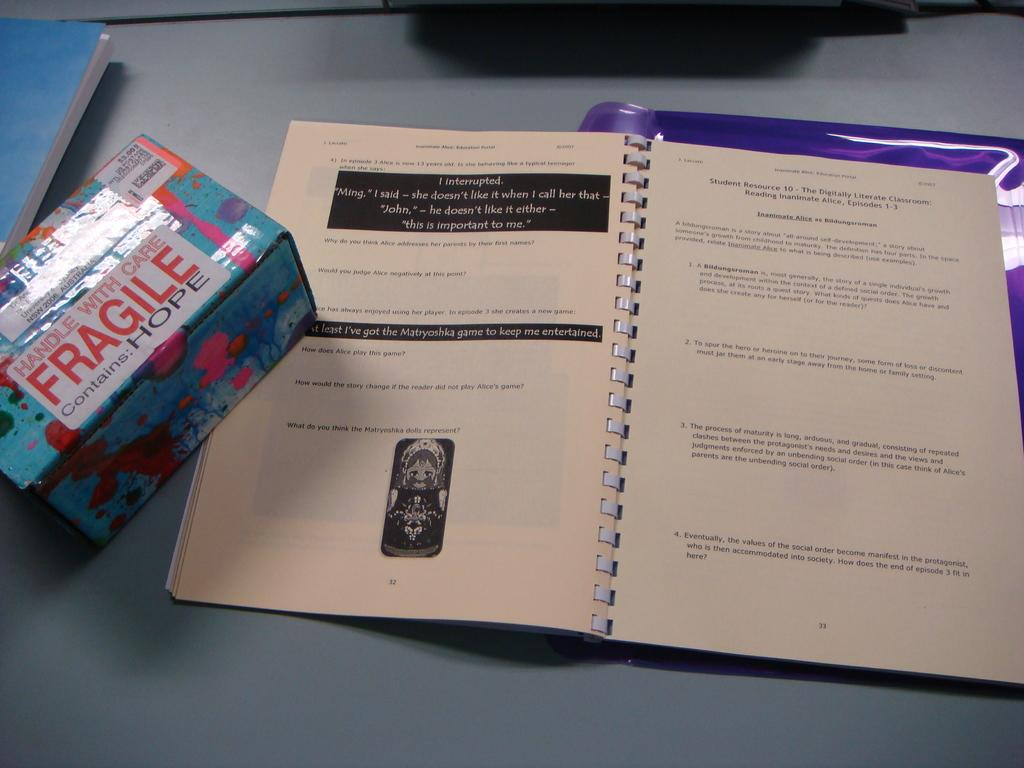<image>
Summarize the visual content of the image. A small box with a fragile sign is partially covering a small part of an open workbook. 